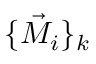Convert formula to latex. <formula><loc_0><loc_0><loc_500><loc_500>\{ \vec { M } _ { i } \} _ { k }</formula> 